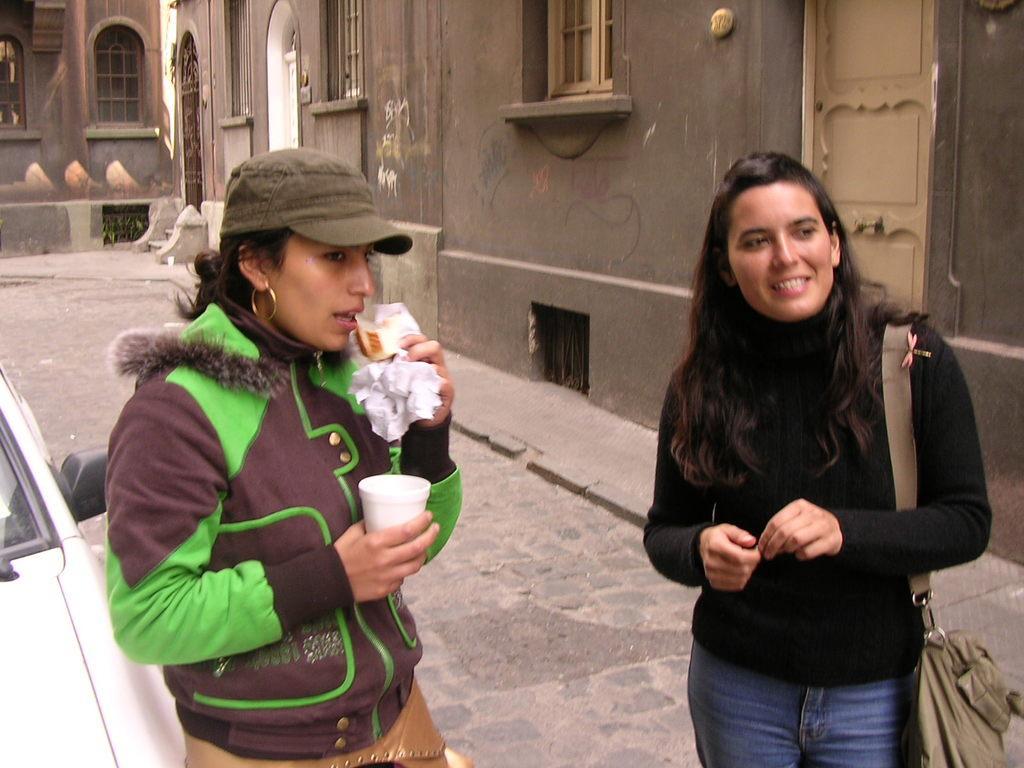Describe this image in one or two sentences. In this picture there is a woman in the left corner is holding a cup in one of her hand and few objects in her another hand and there is vehicle beside her and there is another woman wearing black dress is standing and carrying a bag in the right corner and there is a building in the background. 